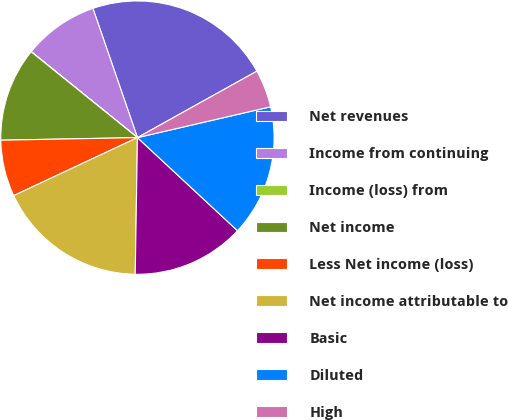Convert chart to OTSL. <chart><loc_0><loc_0><loc_500><loc_500><pie_chart><fcel>Net revenues<fcel>Income from continuing<fcel>Income (loss) from<fcel>Net income<fcel>Less Net income (loss)<fcel>Net income attributable to<fcel>Basic<fcel>Diluted<fcel>High<nl><fcel>22.2%<fcel>8.89%<fcel>0.02%<fcel>11.11%<fcel>6.67%<fcel>17.77%<fcel>13.33%<fcel>15.55%<fcel>4.46%<nl></chart> 